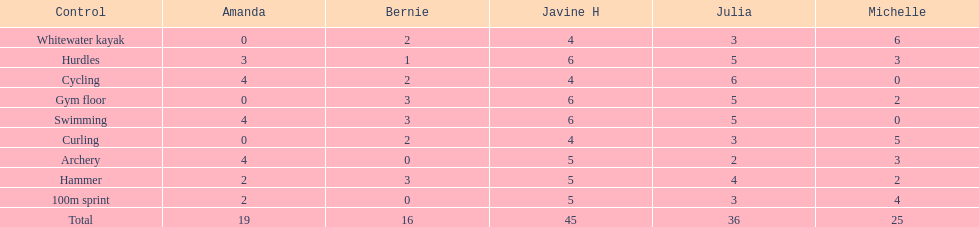Who accumulated the highest overall points? Javine H. 